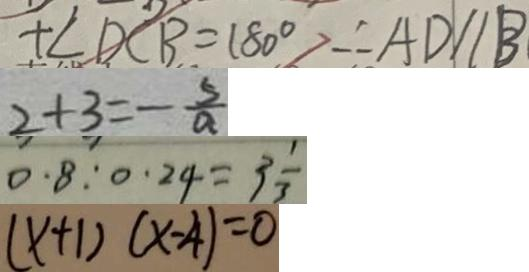Convert formula to latex. <formula><loc_0><loc_0><loc_500><loc_500>+ \angle D C B = 1 8 0 ^ { \circ } \therefore A D / / B 
 2 + 3 = - \frac { 5 } { a } 
 0 . 8 : 0 . 2 4 = 3 \frac { 1 } { 3 } 
 ( x + 1 ) ( x - 4 ) = 0</formula> 